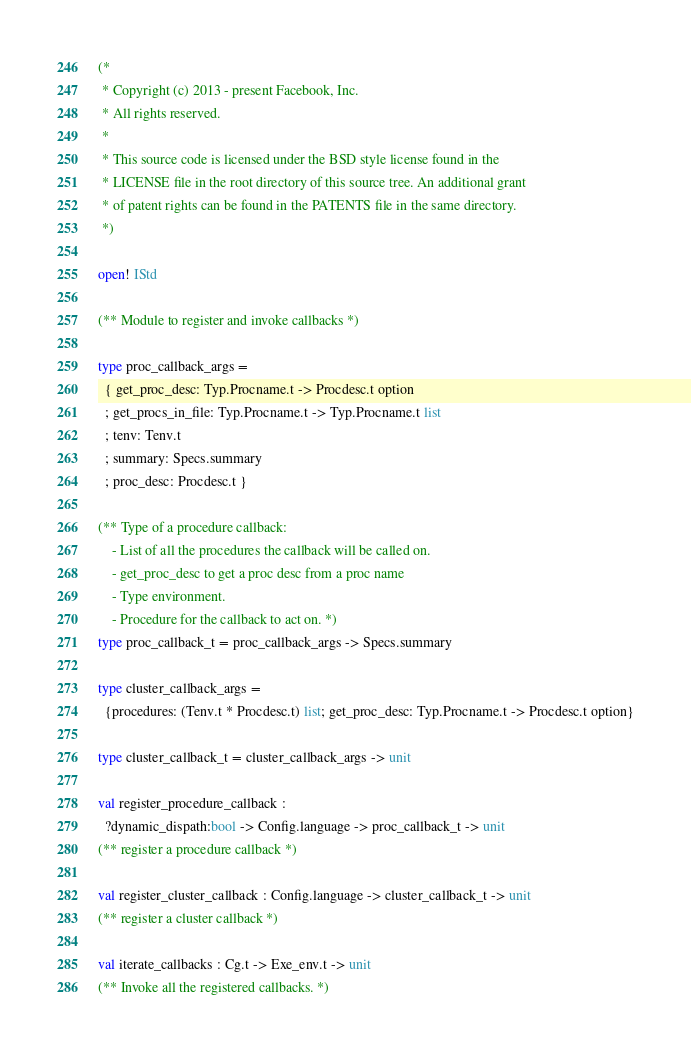<code> <loc_0><loc_0><loc_500><loc_500><_OCaml_>(*
 * Copyright (c) 2013 - present Facebook, Inc.
 * All rights reserved.
 *
 * This source code is licensed under the BSD style license found in the
 * LICENSE file in the root directory of this source tree. An additional grant
 * of patent rights can be found in the PATENTS file in the same directory.
 *)

open! IStd

(** Module to register and invoke callbacks *)

type proc_callback_args =
  { get_proc_desc: Typ.Procname.t -> Procdesc.t option
  ; get_procs_in_file: Typ.Procname.t -> Typ.Procname.t list
  ; tenv: Tenv.t
  ; summary: Specs.summary
  ; proc_desc: Procdesc.t }

(** Type of a procedure callback:
    - List of all the procedures the callback will be called on.
    - get_proc_desc to get a proc desc from a proc name
    - Type environment.
    - Procedure for the callback to act on. *)
type proc_callback_t = proc_callback_args -> Specs.summary

type cluster_callback_args =
  {procedures: (Tenv.t * Procdesc.t) list; get_proc_desc: Typ.Procname.t -> Procdesc.t option}

type cluster_callback_t = cluster_callback_args -> unit

val register_procedure_callback :
  ?dynamic_dispath:bool -> Config.language -> proc_callback_t -> unit
(** register a procedure callback *)

val register_cluster_callback : Config.language -> cluster_callback_t -> unit
(** register a cluster callback *)

val iterate_callbacks : Cg.t -> Exe_env.t -> unit
(** Invoke all the registered callbacks. *)
</code> 